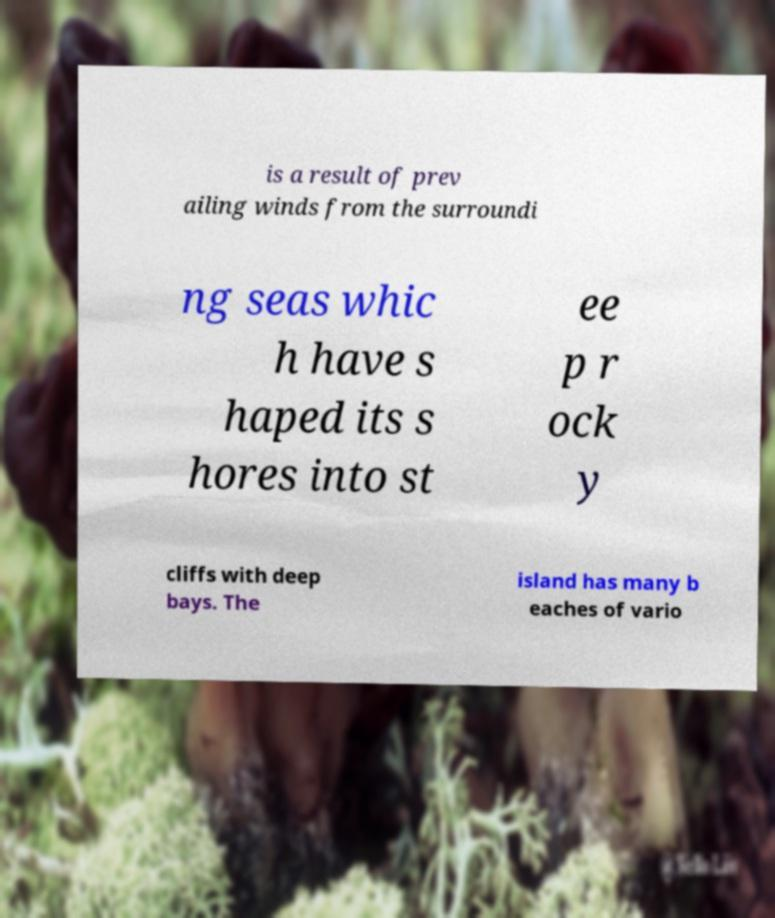What messages or text are displayed in this image? I need them in a readable, typed format. is a result of prev ailing winds from the surroundi ng seas whic h have s haped its s hores into st ee p r ock y cliffs with deep bays. The island has many b eaches of vario 